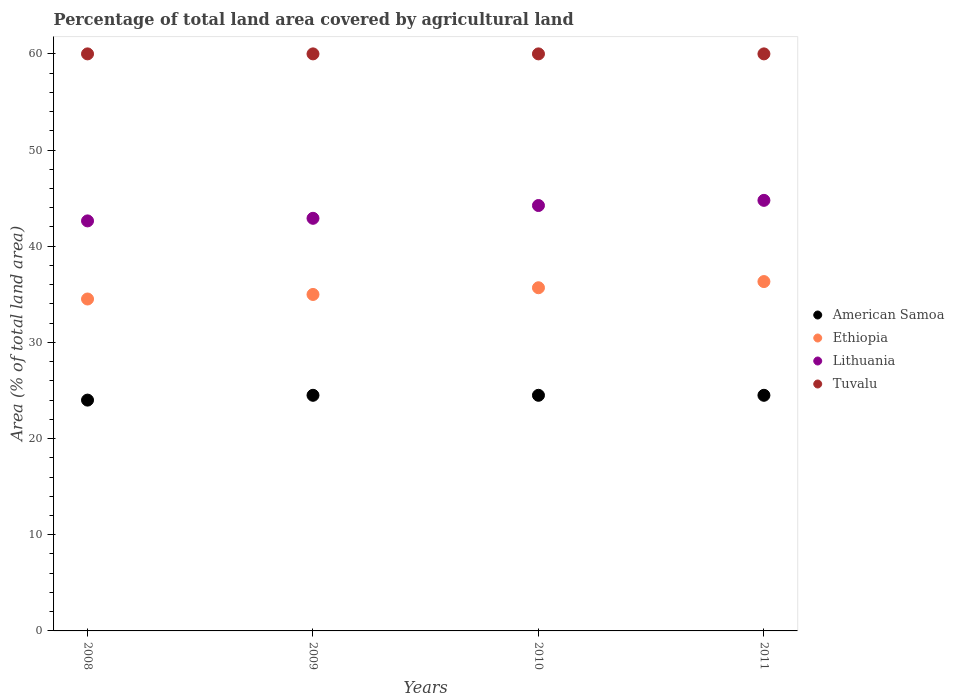How many different coloured dotlines are there?
Your answer should be very brief. 4. Is the number of dotlines equal to the number of legend labels?
Your answer should be compact. Yes. What is the percentage of agricultural land in Ethiopia in 2008?
Offer a terse response. 34.51. Across all years, what is the maximum percentage of agricultural land in Ethiopia?
Offer a very short reply. 36.33. Across all years, what is the minimum percentage of agricultural land in Tuvalu?
Offer a very short reply. 60. In which year was the percentage of agricultural land in American Samoa maximum?
Give a very brief answer. 2009. In which year was the percentage of agricultural land in American Samoa minimum?
Make the answer very short. 2008. What is the total percentage of agricultural land in Tuvalu in the graph?
Ensure brevity in your answer.  240. What is the difference between the percentage of agricultural land in Ethiopia in 2008 and the percentage of agricultural land in Tuvalu in 2009?
Provide a short and direct response. -25.49. What is the average percentage of agricultural land in Lithuania per year?
Ensure brevity in your answer.  43.64. In the year 2010, what is the difference between the percentage of agricultural land in Lithuania and percentage of agricultural land in Ethiopia?
Make the answer very short. 8.55. What is the ratio of the percentage of agricultural land in Ethiopia in 2010 to that in 2011?
Provide a short and direct response. 0.98. Is the percentage of agricultural land in Lithuania in 2008 less than that in 2009?
Ensure brevity in your answer.  Yes. Is the difference between the percentage of agricultural land in Lithuania in 2008 and 2010 greater than the difference between the percentage of agricultural land in Ethiopia in 2008 and 2010?
Your response must be concise. No. What is the difference between the highest and the second highest percentage of agricultural land in Lithuania?
Your answer should be very brief. 0.54. Is the sum of the percentage of agricultural land in American Samoa in 2009 and 2011 greater than the maximum percentage of agricultural land in Ethiopia across all years?
Provide a succinct answer. Yes. Is it the case that in every year, the sum of the percentage of agricultural land in Ethiopia and percentage of agricultural land in Tuvalu  is greater than the percentage of agricultural land in Lithuania?
Offer a very short reply. Yes. Does the percentage of agricultural land in Ethiopia monotonically increase over the years?
Your answer should be compact. Yes. How many dotlines are there?
Offer a terse response. 4. What is the difference between two consecutive major ticks on the Y-axis?
Keep it short and to the point. 10. Does the graph contain any zero values?
Provide a succinct answer. No. Does the graph contain grids?
Make the answer very short. No. Where does the legend appear in the graph?
Offer a terse response. Center right. What is the title of the graph?
Your answer should be compact. Percentage of total land area covered by agricultural land. What is the label or title of the X-axis?
Your answer should be very brief. Years. What is the label or title of the Y-axis?
Keep it short and to the point. Area (% of total land area). What is the Area (% of total land area) in Ethiopia in 2008?
Your answer should be compact. 34.51. What is the Area (% of total land area) in Lithuania in 2008?
Your response must be concise. 42.63. What is the Area (% of total land area) of Tuvalu in 2008?
Your answer should be very brief. 60. What is the Area (% of total land area) of Ethiopia in 2009?
Give a very brief answer. 34.98. What is the Area (% of total land area) of Lithuania in 2009?
Provide a short and direct response. 42.9. What is the Area (% of total land area) of Tuvalu in 2009?
Offer a terse response. 60. What is the Area (% of total land area) in Ethiopia in 2010?
Keep it short and to the point. 35.68. What is the Area (% of total land area) in Lithuania in 2010?
Offer a terse response. 44.23. What is the Area (% of total land area) in Tuvalu in 2010?
Your answer should be very brief. 60. What is the Area (% of total land area) in Ethiopia in 2011?
Make the answer very short. 36.33. What is the Area (% of total land area) in Lithuania in 2011?
Your response must be concise. 44.77. What is the Area (% of total land area) in Tuvalu in 2011?
Make the answer very short. 60. Across all years, what is the maximum Area (% of total land area) in American Samoa?
Make the answer very short. 24.5. Across all years, what is the maximum Area (% of total land area) in Ethiopia?
Offer a terse response. 36.33. Across all years, what is the maximum Area (% of total land area) in Lithuania?
Your response must be concise. 44.77. Across all years, what is the minimum Area (% of total land area) in Ethiopia?
Give a very brief answer. 34.51. Across all years, what is the minimum Area (% of total land area) in Lithuania?
Provide a short and direct response. 42.63. What is the total Area (% of total land area) in American Samoa in the graph?
Ensure brevity in your answer.  97.5. What is the total Area (% of total land area) in Ethiopia in the graph?
Your answer should be very brief. 141.51. What is the total Area (% of total land area) in Lithuania in the graph?
Provide a short and direct response. 174.54. What is the total Area (% of total land area) of Tuvalu in the graph?
Make the answer very short. 240. What is the difference between the Area (% of total land area) in American Samoa in 2008 and that in 2009?
Give a very brief answer. -0.5. What is the difference between the Area (% of total land area) in Ethiopia in 2008 and that in 2009?
Ensure brevity in your answer.  -0.47. What is the difference between the Area (% of total land area) in Lithuania in 2008 and that in 2009?
Provide a short and direct response. -0.27. What is the difference between the Area (% of total land area) of Tuvalu in 2008 and that in 2009?
Make the answer very short. 0. What is the difference between the Area (% of total land area) of Ethiopia in 2008 and that in 2010?
Your response must be concise. -1.17. What is the difference between the Area (% of total land area) in Lithuania in 2008 and that in 2010?
Your answer should be compact. -1.6. What is the difference between the Area (% of total land area) in American Samoa in 2008 and that in 2011?
Your answer should be very brief. -0.5. What is the difference between the Area (% of total land area) of Ethiopia in 2008 and that in 2011?
Provide a succinct answer. -1.81. What is the difference between the Area (% of total land area) of Lithuania in 2008 and that in 2011?
Provide a short and direct response. -2.14. What is the difference between the Area (% of total land area) in Tuvalu in 2008 and that in 2011?
Offer a terse response. 0. What is the difference between the Area (% of total land area) of Ethiopia in 2009 and that in 2010?
Provide a succinct answer. -0.7. What is the difference between the Area (% of total land area) in Lithuania in 2009 and that in 2010?
Keep it short and to the point. -1.33. What is the difference between the Area (% of total land area) in Tuvalu in 2009 and that in 2010?
Your answer should be compact. 0. What is the difference between the Area (% of total land area) of Ethiopia in 2009 and that in 2011?
Your answer should be compact. -1.34. What is the difference between the Area (% of total land area) of Lithuania in 2009 and that in 2011?
Offer a terse response. -1.87. What is the difference between the Area (% of total land area) of Tuvalu in 2009 and that in 2011?
Ensure brevity in your answer.  0. What is the difference between the Area (% of total land area) of American Samoa in 2010 and that in 2011?
Ensure brevity in your answer.  0. What is the difference between the Area (% of total land area) in Ethiopia in 2010 and that in 2011?
Your answer should be very brief. -0.64. What is the difference between the Area (% of total land area) in Lithuania in 2010 and that in 2011?
Offer a very short reply. -0.54. What is the difference between the Area (% of total land area) of American Samoa in 2008 and the Area (% of total land area) of Ethiopia in 2009?
Make the answer very short. -10.98. What is the difference between the Area (% of total land area) of American Samoa in 2008 and the Area (% of total land area) of Lithuania in 2009?
Offer a very short reply. -18.9. What is the difference between the Area (% of total land area) in American Samoa in 2008 and the Area (% of total land area) in Tuvalu in 2009?
Provide a short and direct response. -36. What is the difference between the Area (% of total land area) of Ethiopia in 2008 and the Area (% of total land area) of Lithuania in 2009?
Make the answer very short. -8.39. What is the difference between the Area (% of total land area) of Ethiopia in 2008 and the Area (% of total land area) of Tuvalu in 2009?
Your answer should be very brief. -25.49. What is the difference between the Area (% of total land area) in Lithuania in 2008 and the Area (% of total land area) in Tuvalu in 2009?
Your answer should be very brief. -17.37. What is the difference between the Area (% of total land area) of American Samoa in 2008 and the Area (% of total land area) of Ethiopia in 2010?
Your answer should be very brief. -11.68. What is the difference between the Area (% of total land area) of American Samoa in 2008 and the Area (% of total land area) of Lithuania in 2010?
Your response must be concise. -20.23. What is the difference between the Area (% of total land area) in American Samoa in 2008 and the Area (% of total land area) in Tuvalu in 2010?
Provide a short and direct response. -36. What is the difference between the Area (% of total land area) of Ethiopia in 2008 and the Area (% of total land area) of Lithuania in 2010?
Your answer should be compact. -9.72. What is the difference between the Area (% of total land area) in Ethiopia in 2008 and the Area (% of total land area) in Tuvalu in 2010?
Your answer should be compact. -25.49. What is the difference between the Area (% of total land area) of Lithuania in 2008 and the Area (% of total land area) of Tuvalu in 2010?
Offer a very short reply. -17.37. What is the difference between the Area (% of total land area) in American Samoa in 2008 and the Area (% of total land area) in Ethiopia in 2011?
Provide a short and direct response. -12.33. What is the difference between the Area (% of total land area) in American Samoa in 2008 and the Area (% of total land area) in Lithuania in 2011?
Ensure brevity in your answer.  -20.77. What is the difference between the Area (% of total land area) in American Samoa in 2008 and the Area (% of total land area) in Tuvalu in 2011?
Ensure brevity in your answer.  -36. What is the difference between the Area (% of total land area) in Ethiopia in 2008 and the Area (% of total land area) in Lithuania in 2011?
Keep it short and to the point. -10.26. What is the difference between the Area (% of total land area) in Ethiopia in 2008 and the Area (% of total land area) in Tuvalu in 2011?
Ensure brevity in your answer.  -25.49. What is the difference between the Area (% of total land area) in Lithuania in 2008 and the Area (% of total land area) in Tuvalu in 2011?
Provide a succinct answer. -17.37. What is the difference between the Area (% of total land area) in American Samoa in 2009 and the Area (% of total land area) in Ethiopia in 2010?
Offer a terse response. -11.18. What is the difference between the Area (% of total land area) of American Samoa in 2009 and the Area (% of total land area) of Lithuania in 2010?
Keep it short and to the point. -19.73. What is the difference between the Area (% of total land area) in American Samoa in 2009 and the Area (% of total land area) in Tuvalu in 2010?
Your answer should be compact. -35.5. What is the difference between the Area (% of total land area) in Ethiopia in 2009 and the Area (% of total land area) in Lithuania in 2010?
Give a very brief answer. -9.25. What is the difference between the Area (% of total land area) in Ethiopia in 2009 and the Area (% of total land area) in Tuvalu in 2010?
Give a very brief answer. -25.02. What is the difference between the Area (% of total land area) of Lithuania in 2009 and the Area (% of total land area) of Tuvalu in 2010?
Your response must be concise. -17.1. What is the difference between the Area (% of total land area) in American Samoa in 2009 and the Area (% of total land area) in Ethiopia in 2011?
Provide a succinct answer. -11.83. What is the difference between the Area (% of total land area) in American Samoa in 2009 and the Area (% of total land area) in Lithuania in 2011?
Offer a very short reply. -20.27. What is the difference between the Area (% of total land area) in American Samoa in 2009 and the Area (% of total land area) in Tuvalu in 2011?
Keep it short and to the point. -35.5. What is the difference between the Area (% of total land area) in Ethiopia in 2009 and the Area (% of total land area) in Lithuania in 2011?
Provide a succinct answer. -9.78. What is the difference between the Area (% of total land area) of Ethiopia in 2009 and the Area (% of total land area) of Tuvalu in 2011?
Give a very brief answer. -25.02. What is the difference between the Area (% of total land area) in Lithuania in 2009 and the Area (% of total land area) in Tuvalu in 2011?
Keep it short and to the point. -17.1. What is the difference between the Area (% of total land area) of American Samoa in 2010 and the Area (% of total land area) of Ethiopia in 2011?
Your answer should be compact. -11.83. What is the difference between the Area (% of total land area) of American Samoa in 2010 and the Area (% of total land area) of Lithuania in 2011?
Ensure brevity in your answer.  -20.27. What is the difference between the Area (% of total land area) of American Samoa in 2010 and the Area (% of total land area) of Tuvalu in 2011?
Your answer should be compact. -35.5. What is the difference between the Area (% of total land area) in Ethiopia in 2010 and the Area (% of total land area) in Lithuania in 2011?
Provide a succinct answer. -9.09. What is the difference between the Area (% of total land area) of Ethiopia in 2010 and the Area (% of total land area) of Tuvalu in 2011?
Your answer should be very brief. -24.32. What is the difference between the Area (% of total land area) of Lithuania in 2010 and the Area (% of total land area) of Tuvalu in 2011?
Your answer should be compact. -15.77. What is the average Area (% of total land area) of American Samoa per year?
Keep it short and to the point. 24.38. What is the average Area (% of total land area) of Ethiopia per year?
Offer a very short reply. 35.38. What is the average Area (% of total land area) in Lithuania per year?
Provide a short and direct response. 43.64. In the year 2008, what is the difference between the Area (% of total land area) of American Samoa and Area (% of total land area) of Ethiopia?
Provide a short and direct response. -10.51. In the year 2008, what is the difference between the Area (% of total land area) of American Samoa and Area (% of total land area) of Lithuania?
Make the answer very short. -18.63. In the year 2008, what is the difference between the Area (% of total land area) in American Samoa and Area (% of total land area) in Tuvalu?
Keep it short and to the point. -36. In the year 2008, what is the difference between the Area (% of total land area) in Ethiopia and Area (% of total land area) in Lithuania?
Offer a very short reply. -8.12. In the year 2008, what is the difference between the Area (% of total land area) of Ethiopia and Area (% of total land area) of Tuvalu?
Offer a very short reply. -25.49. In the year 2008, what is the difference between the Area (% of total land area) of Lithuania and Area (% of total land area) of Tuvalu?
Make the answer very short. -17.37. In the year 2009, what is the difference between the Area (% of total land area) in American Samoa and Area (% of total land area) in Ethiopia?
Your answer should be very brief. -10.48. In the year 2009, what is the difference between the Area (% of total land area) in American Samoa and Area (% of total land area) in Lithuania?
Provide a short and direct response. -18.4. In the year 2009, what is the difference between the Area (% of total land area) in American Samoa and Area (% of total land area) in Tuvalu?
Your answer should be very brief. -35.5. In the year 2009, what is the difference between the Area (% of total land area) of Ethiopia and Area (% of total land area) of Lithuania?
Keep it short and to the point. -7.92. In the year 2009, what is the difference between the Area (% of total land area) in Ethiopia and Area (% of total land area) in Tuvalu?
Provide a short and direct response. -25.02. In the year 2009, what is the difference between the Area (% of total land area) in Lithuania and Area (% of total land area) in Tuvalu?
Your answer should be very brief. -17.1. In the year 2010, what is the difference between the Area (% of total land area) in American Samoa and Area (% of total land area) in Ethiopia?
Make the answer very short. -11.18. In the year 2010, what is the difference between the Area (% of total land area) in American Samoa and Area (% of total land area) in Lithuania?
Your response must be concise. -19.73. In the year 2010, what is the difference between the Area (% of total land area) of American Samoa and Area (% of total land area) of Tuvalu?
Give a very brief answer. -35.5. In the year 2010, what is the difference between the Area (% of total land area) in Ethiopia and Area (% of total land area) in Lithuania?
Your answer should be very brief. -8.55. In the year 2010, what is the difference between the Area (% of total land area) of Ethiopia and Area (% of total land area) of Tuvalu?
Provide a succinct answer. -24.32. In the year 2010, what is the difference between the Area (% of total land area) of Lithuania and Area (% of total land area) of Tuvalu?
Your response must be concise. -15.77. In the year 2011, what is the difference between the Area (% of total land area) of American Samoa and Area (% of total land area) of Ethiopia?
Ensure brevity in your answer.  -11.83. In the year 2011, what is the difference between the Area (% of total land area) in American Samoa and Area (% of total land area) in Lithuania?
Ensure brevity in your answer.  -20.27. In the year 2011, what is the difference between the Area (% of total land area) in American Samoa and Area (% of total land area) in Tuvalu?
Give a very brief answer. -35.5. In the year 2011, what is the difference between the Area (% of total land area) in Ethiopia and Area (% of total land area) in Lithuania?
Your response must be concise. -8.44. In the year 2011, what is the difference between the Area (% of total land area) in Ethiopia and Area (% of total land area) in Tuvalu?
Offer a terse response. -23.67. In the year 2011, what is the difference between the Area (% of total land area) of Lithuania and Area (% of total land area) of Tuvalu?
Make the answer very short. -15.23. What is the ratio of the Area (% of total land area) of American Samoa in 2008 to that in 2009?
Provide a succinct answer. 0.98. What is the ratio of the Area (% of total land area) of Ethiopia in 2008 to that in 2009?
Offer a very short reply. 0.99. What is the ratio of the Area (% of total land area) of American Samoa in 2008 to that in 2010?
Offer a terse response. 0.98. What is the ratio of the Area (% of total land area) in Ethiopia in 2008 to that in 2010?
Your answer should be compact. 0.97. What is the ratio of the Area (% of total land area) in Lithuania in 2008 to that in 2010?
Provide a short and direct response. 0.96. What is the ratio of the Area (% of total land area) in Tuvalu in 2008 to that in 2010?
Ensure brevity in your answer.  1. What is the ratio of the Area (% of total land area) of American Samoa in 2008 to that in 2011?
Give a very brief answer. 0.98. What is the ratio of the Area (% of total land area) in Ethiopia in 2008 to that in 2011?
Your answer should be compact. 0.95. What is the ratio of the Area (% of total land area) of Lithuania in 2008 to that in 2011?
Keep it short and to the point. 0.95. What is the ratio of the Area (% of total land area) of American Samoa in 2009 to that in 2010?
Your response must be concise. 1. What is the ratio of the Area (% of total land area) in Ethiopia in 2009 to that in 2010?
Ensure brevity in your answer.  0.98. What is the ratio of the Area (% of total land area) in American Samoa in 2009 to that in 2011?
Your answer should be very brief. 1. What is the ratio of the Area (% of total land area) of Ethiopia in 2009 to that in 2011?
Your answer should be very brief. 0.96. What is the ratio of the Area (% of total land area) in Tuvalu in 2009 to that in 2011?
Provide a short and direct response. 1. What is the ratio of the Area (% of total land area) in American Samoa in 2010 to that in 2011?
Make the answer very short. 1. What is the ratio of the Area (% of total land area) of Ethiopia in 2010 to that in 2011?
Give a very brief answer. 0.98. What is the ratio of the Area (% of total land area) of Tuvalu in 2010 to that in 2011?
Give a very brief answer. 1. What is the difference between the highest and the second highest Area (% of total land area) of Ethiopia?
Ensure brevity in your answer.  0.64. What is the difference between the highest and the second highest Area (% of total land area) in Lithuania?
Make the answer very short. 0.54. What is the difference between the highest and the lowest Area (% of total land area) of Ethiopia?
Keep it short and to the point. 1.81. What is the difference between the highest and the lowest Area (% of total land area) in Lithuania?
Provide a succinct answer. 2.14. What is the difference between the highest and the lowest Area (% of total land area) of Tuvalu?
Give a very brief answer. 0. 